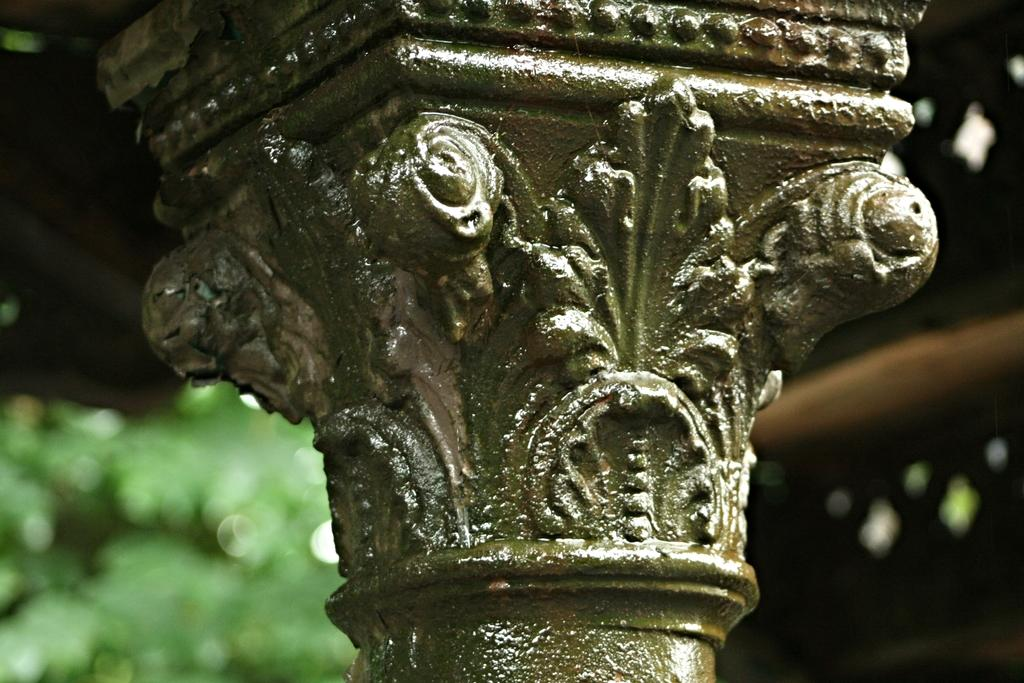What is the main structure in the image? There is a pillar in the image. What can be seen on the pillar? The pillar has carvings on it. What type of natural elements are visible in the image? There are trees visible in the image. What type of hat is the pillar wearing in the image? The pillar is not wearing a hat, as it is an inanimate object and cannot wear clothing. 